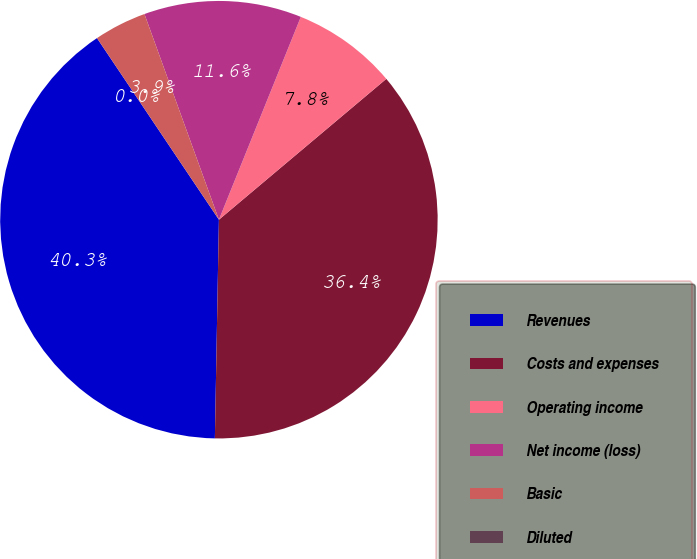Convert chart to OTSL. <chart><loc_0><loc_0><loc_500><loc_500><pie_chart><fcel>Revenues<fcel>Costs and expenses<fcel>Operating income<fcel>Net income (loss)<fcel>Basic<fcel>Diluted<nl><fcel>40.3%<fcel>36.43%<fcel>7.76%<fcel>11.64%<fcel>3.88%<fcel>0.0%<nl></chart> 